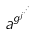<formula> <loc_0><loc_0><loc_500><loc_500>a ^ { g ^ { j ^ { \cdot ^ { \cdot ^ { \cdot } } } } }</formula> 